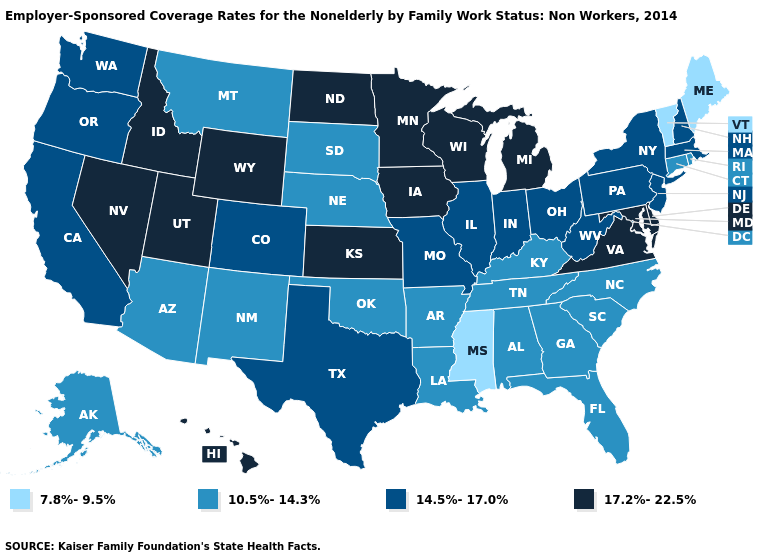Name the states that have a value in the range 10.5%-14.3%?
Write a very short answer. Alabama, Alaska, Arizona, Arkansas, Connecticut, Florida, Georgia, Kentucky, Louisiana, Montana, Nebraska, New Mexico, North Carolina, Oklahoma, Rhode Island, South Carolina, South Dakota, Tennessee. What is the highest value in the South ?
Answer briefly. 17.2%-22.5%. Name the states that have a value in the range 10.5%-14.3%?
Quick response, please. Alabama, Alaska, Arizona, Arkansas, Connecticut, Florida, Georgia, Kentucky, Louisiana, Montana, Nebraska, New Mexico, North Carolina, Oklahoma, Rhode Island, South Carolina, South Dakota, Tennessee. Does Michigan have the highest value in the USA?
Give a very brief answer. Yes. Does Montana have a higher value than Vermont?
Short answer required. Yes. What is the value of Wyoming?
Write a very short answer. 17.2%-22.5%. What is the value of Iowa?
Short answer required. 17.2%-22.5%. Among the states that border Florida , which have the highest value?
Write a very short answer. Alabama, Georgia. Does Iowa have a higher value than Utah?
Answer briefly. No. Does Pennsylvania have the highest value in the Northeast?
Concise answer only. Yes. What is the highest value in the Northeast ?
Give a very brief answer. 14.5%-17.0%. Does Maine have the same value as Vermont?
Keep it brief. Yes. Does the map have missing data?
Give a very brief answer. No. Among the states that border North Carolina , does Virginia have the lowest value?
Short answer required. No. Does Georgia have a higher value than Mississippi?
Be succinct. Yes. 